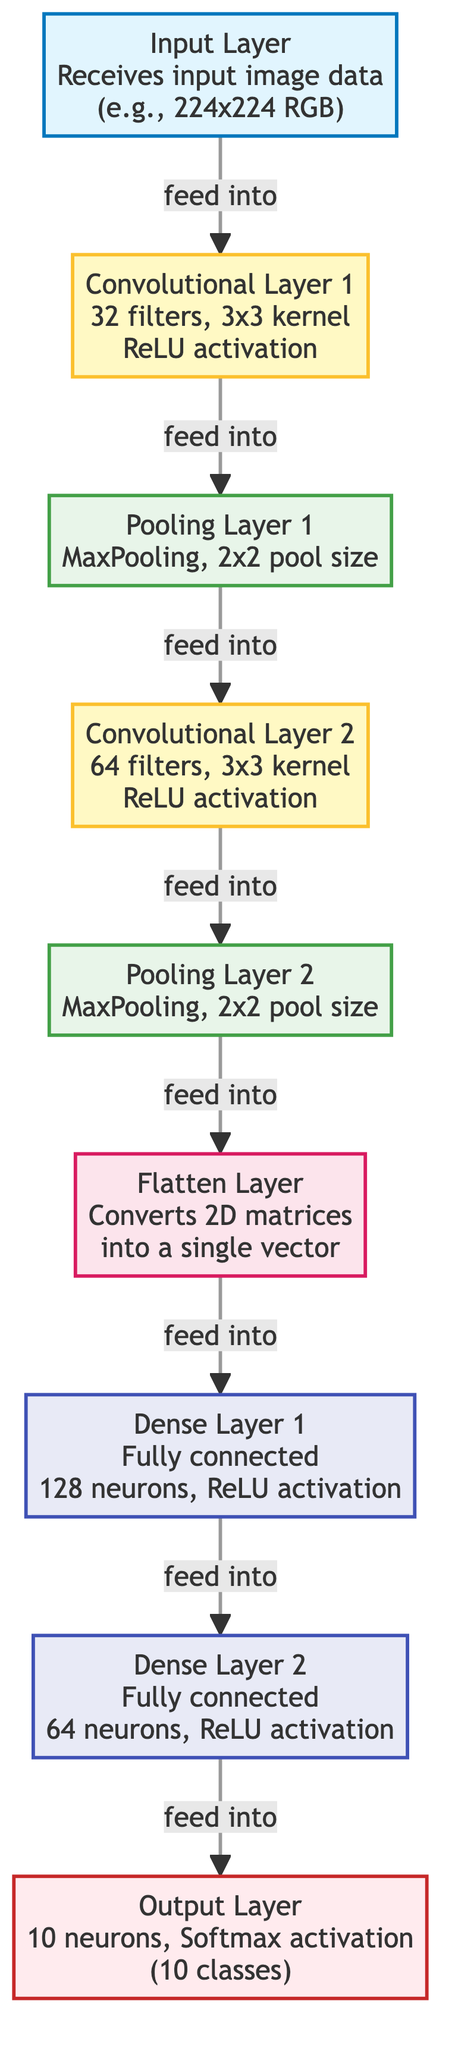What is the size of the input image in the Input Layer? The Input Layer specifies the size of the images it receives, which is 224x224 RGB. This can be directly read from the label attached to the Input Layer.
Answer: 224x224 RGB How many filters are used in the first Convolutional Layer? The label for Convolutional Layer 1 indicates that it uses 32 filters. This number is stated directly in the diagram next to the layer description.
Answer: 32 What type of activation function is used in the Output Layer? The Output Layer specifies the use of Softmax activation. This is highlighted in the description of the Output Layer within the diagram.
Answer: Softmax Which layer follows the second Pooling Layer? The diagram shows that the Flatten Layer is the next layer after Pooling Layer 2, providing a clear flow from Pooling Layer 2 to Flatten Layer.
Answer: Flatten Layer How many neurons are in Dense Layer 1? The description of Dense Layer 1 indicates that there are 128 neurons, which is explicitly mentioned in the diagram associated with that layer.
Answer: 128 What is the pooling method used in Pooling Layer 1? The description for Pooling Layer 1 states it uses MaxPooling as the pooling method. This can be found in the label for Pooling Layer 1 in the diagram.
Answer: MaxPooling Which layer has a total of 10 neurons? The Output Layer is the only layer that has 10 neurons, as indicated in its description, which makes it the answer to this question.
Answer: Output Layer What happens to the 2D matrices in the Flatten Layer? The Flatten Layer's function is to convert the 2D matrices into a single vector, which is stated in the label for the Flatten Layer.
Answer: Converts 2D matrices into a single vector What is the relationship between Conv Layer 2 and Pool Layer 2? The flow established in the diagram shows that Conv Layer 2 feeds into Pool Layer 2, indicating a direct connection where the output of Conv Layer 2 is inputted into Pool Layer 2.
Answer: Feed into 